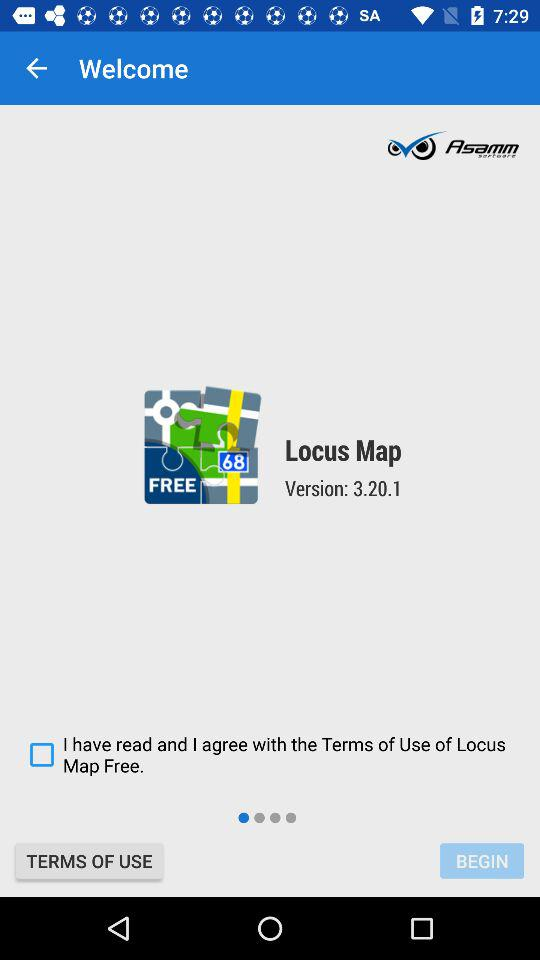What is the status of "I have read and I agree with the Terms of Use of Locus Map Free."? The status is "off". 